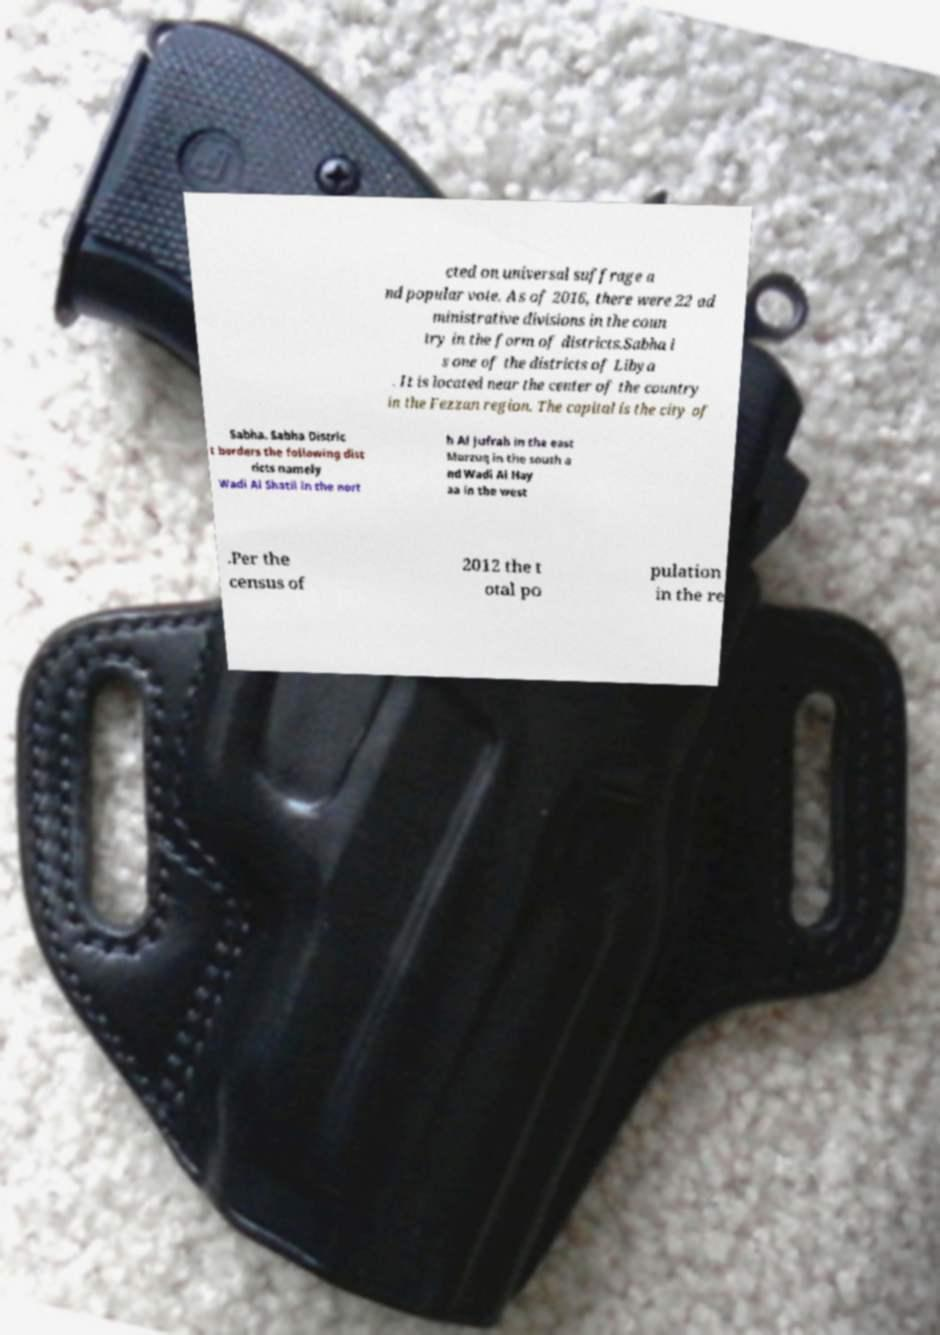Please read and relay the text visible in this image. What does it say? cted on universal suffrage a nd popular vote. As of 2016, there were 22 ad ministrative divisions in the coun try in the form of districts.Sabha i s one of the districts of Libya . It is located near the center of the country in the Fezzan region. The capital is the city of Sabha. Sabha Distric t borders the following dist ricts namely Wadi Al Shatii in the nort h Al Jufrah in the east Murzuq in the south a nd Wadi Al Hay aa in the west .Per the census of 2012 the t otal po pulation in the re 